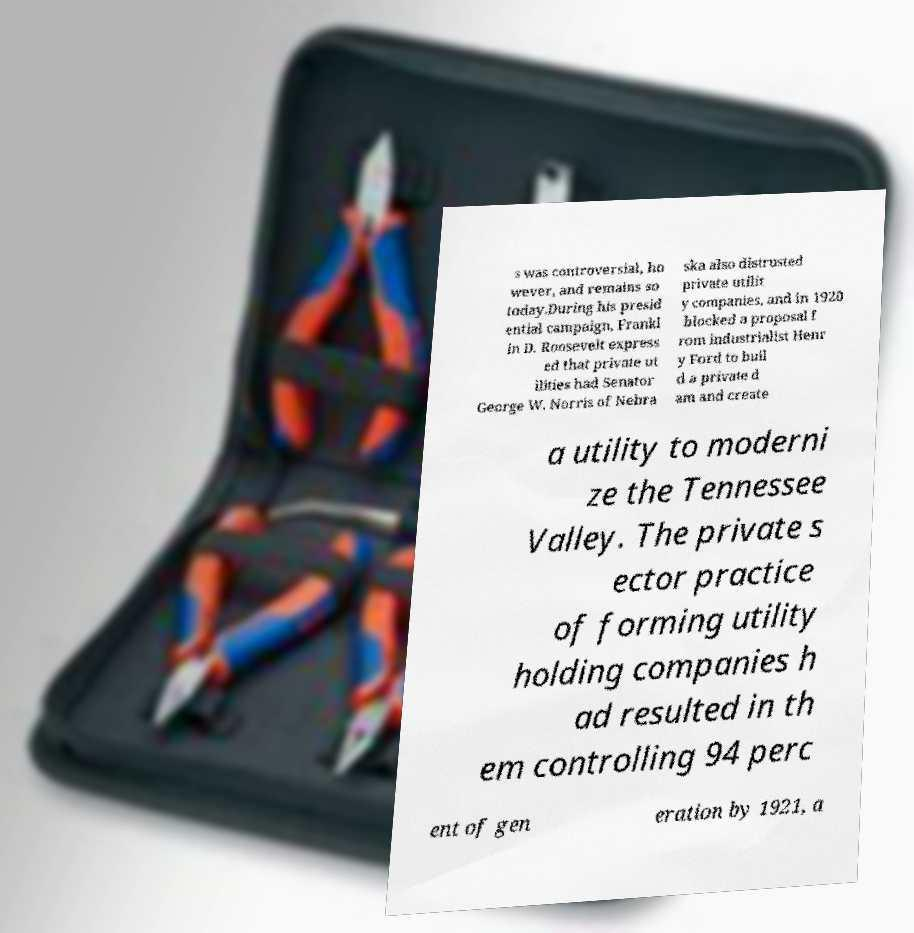What messages or text are displayed in this image? I need them in a readable, typed format. s was controversial, ho wever, and remains so today.During his presid ential campaign, Frankl in D. Roosevelt express ed that private ut ilities had Senator George W. Norris of Nebra ska also distrusted private utilit y companies, and in 1920 blocked a proposal f rom industrialist Henr y Ford to buil d a private d am and create a utility to moderni ze the Tennessee Valley. The private s ector practice of forming utility holding companies h ad resulted in th em controlling 94 perc ent of gen eration by 1921, a 